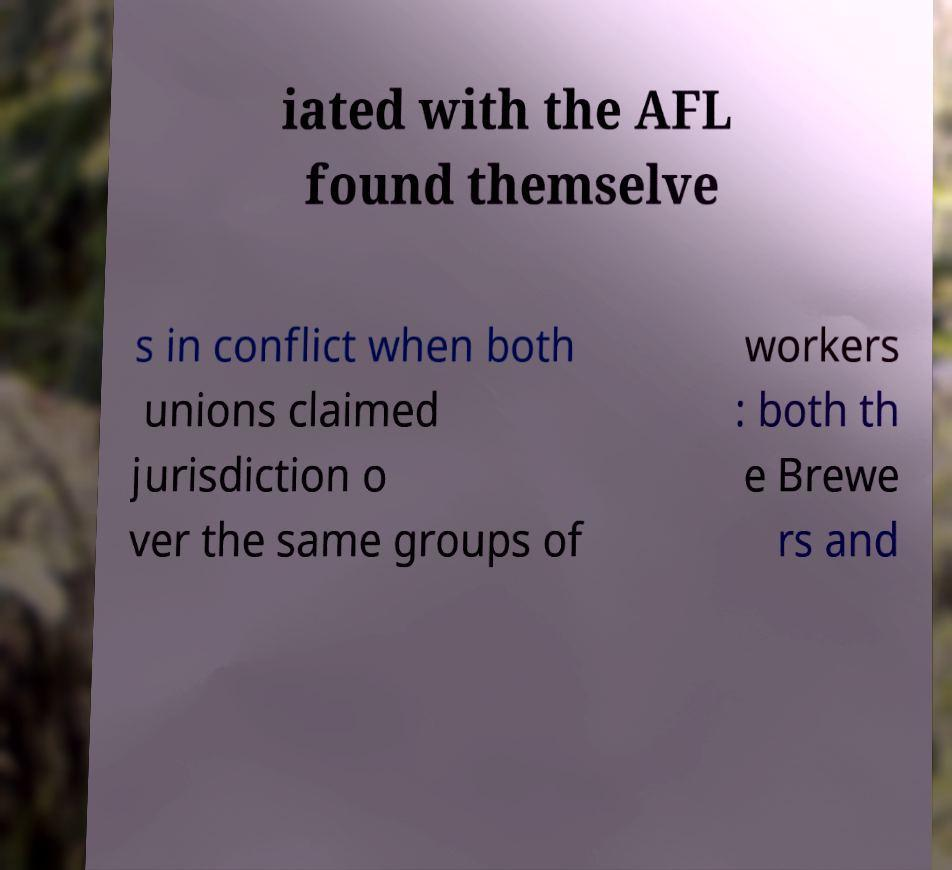Please read and relay the text visible in this image. What does it say? iated with the AFL found themselve s in conflict when both unions claimed jurisdiction o ver the same groups of workers : both th e Brewe rs and 